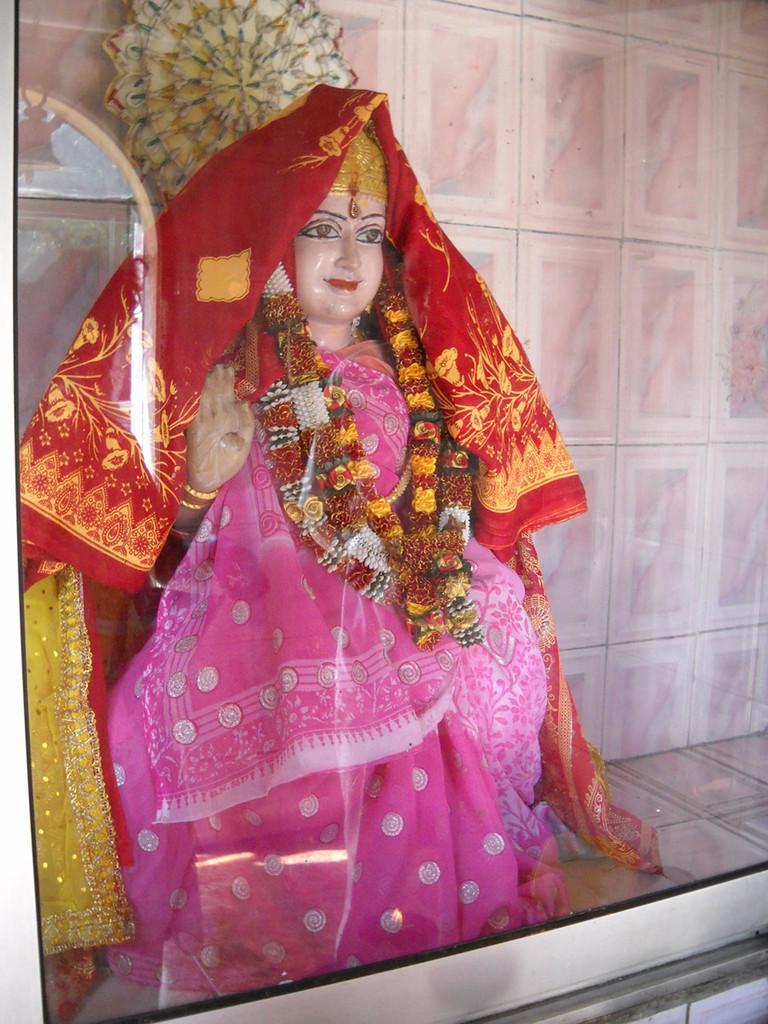Can you describe this image briefly? This is the picture of an idol which most of the Indians worship. The idol is covered with sarees and its decorated with garlands. The idol is placed in a glass shelf and in the background we can observe the wall which is covered with the tiles. 